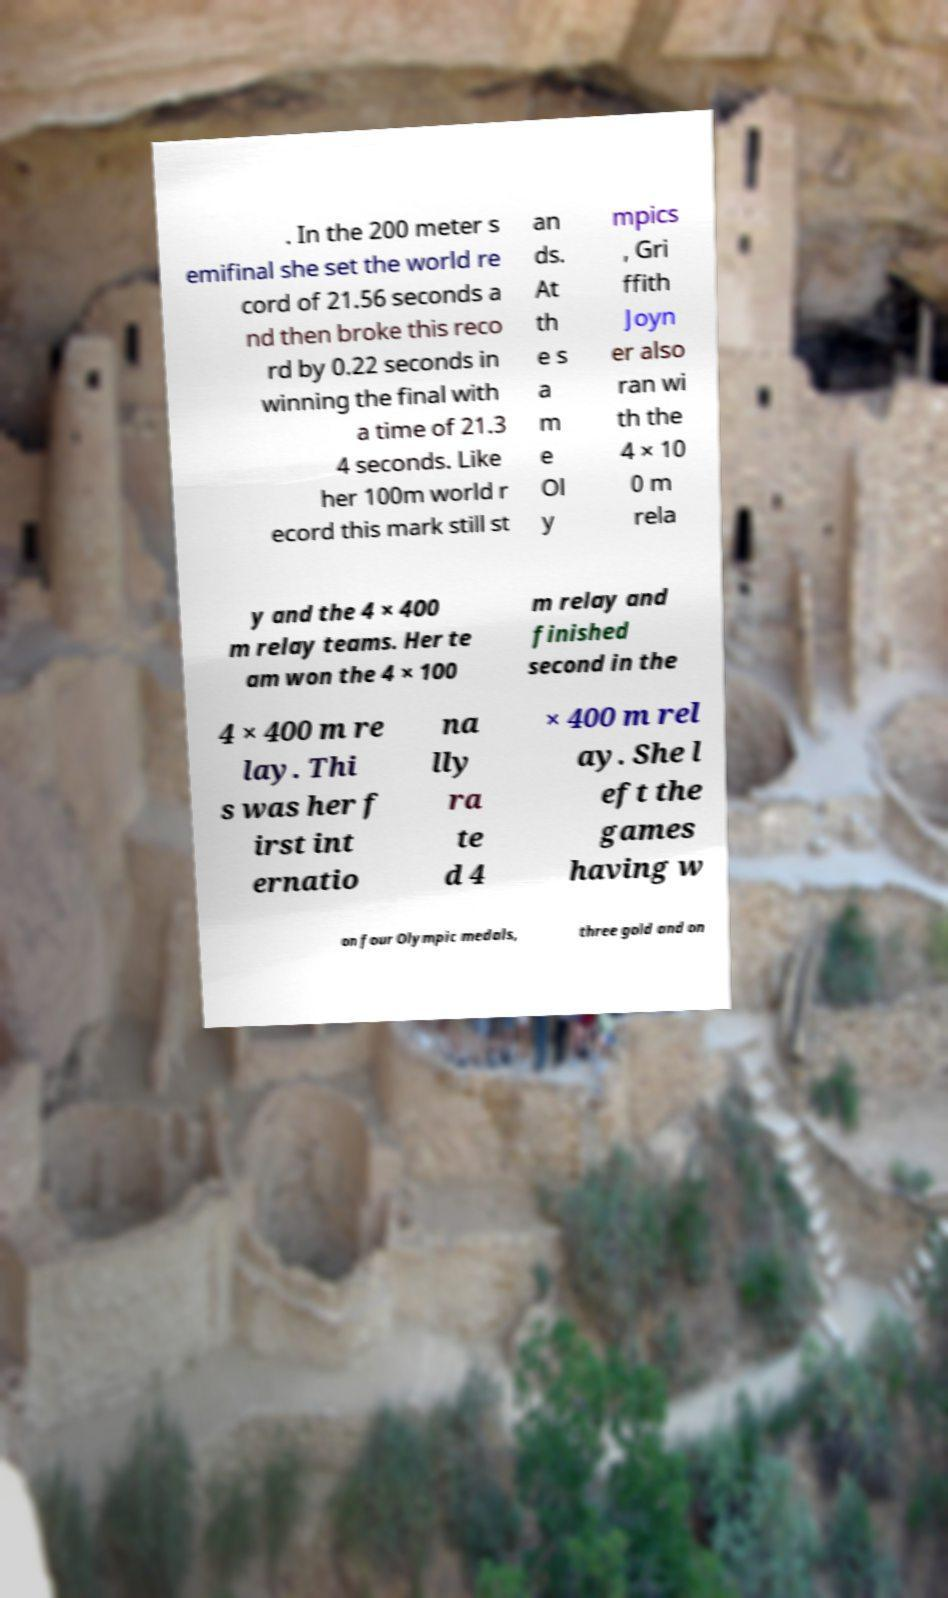Could you assist in decoding the text presented in this image and type it out clearly? . In the 200 meter s emifinal she set the world re cord of 21.56 seconds a nd then broke this reco rd by 0.22 seconds in winning the final with a time of 21.3 4 seconds. Like her 100m world r ecord this mark still st an ds. At th e s a m e Ol y mpics , Gri ffith Joyn er also ran wi th the 4 × 10 0 m rela y and the 4 × 400 m relay teams. Her te am won the 4 × 100 m relay and finished second in the 4 × 400 m re lay. Thi s was her f irst int ernatio na lly ra te d 4 × 400 m rel ay. She l eft the games having w on four Olympic medals, three gold and on 